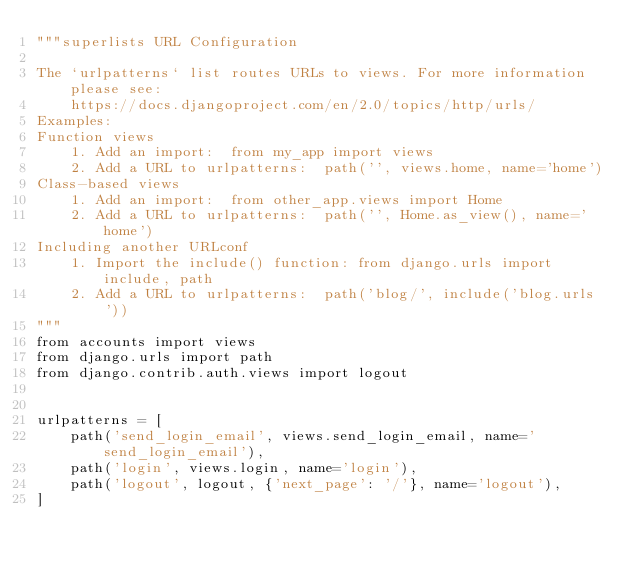Convert code to text. <code><loc_0><loc_0><loc_500><loc_500><_Python_>"""superlists URL Configuration

The `urlpatterns` list routes URLs to views. For more information please see:
    https://docs.djangoproject.com/en/2.0/topics/http/urls/
Examples:
Function views
    1. Add an import:  from my_app import views
    2. Add a URL to urlpatterns:  path('', views.home, name='home')
Class-based views
    1. Add an import:  from other_app.views import Home
    2. Add a URL to urlpatterns:  path('', Home.as_view(), name='home')
Including another URLconf
    1. Import the include() function: from django.urls import include, path
    2. Add a URL to urlpatterns:  path('blog/', include('blog.urls'))
"""
from accounts import views
from django.urls import path
from django.contrib.auth.views import logout


urlpatterns = [
    path('send_login_email', views.send_login_email, name='send_login_email'),
    path('login', views.login, name='login'),
    path('logout', logout, {'next_page': '/'}, name='logout'),
]
</code> 